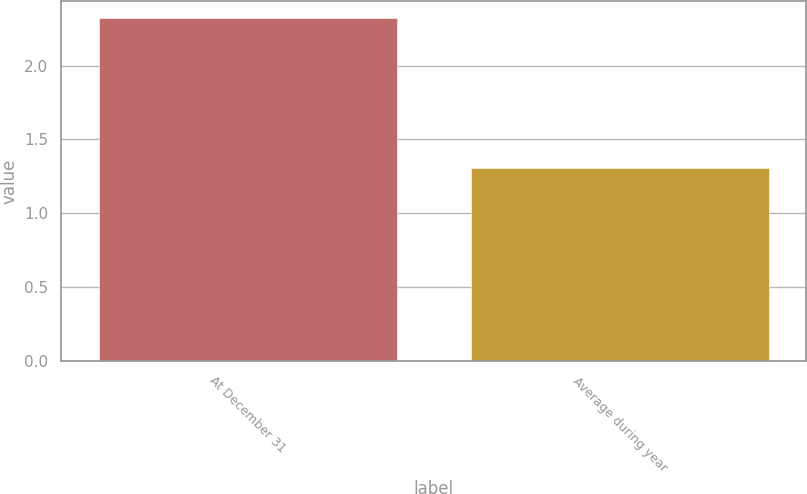Convert chart to OTSL. <chart><loc_0><loc_0><loc_500><loc_500><bar_chart><fcel>At December 31<fcel>Average during year<nl><fcel>2.32<fcel>1.31<nl></chart> 